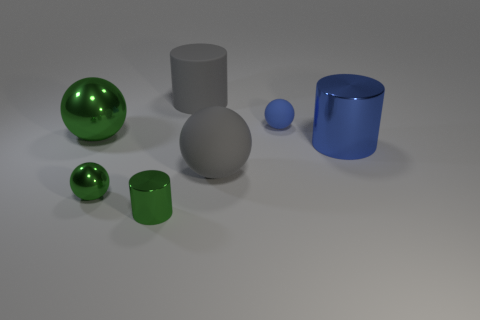Are there any patterns or themes that can be observed among the items in this image? Yes, there appears to be a theme of basic geometric shapes and a contrast between objects with matte and shiny surfaces, which could suggest an exploration of material properties and forms. 